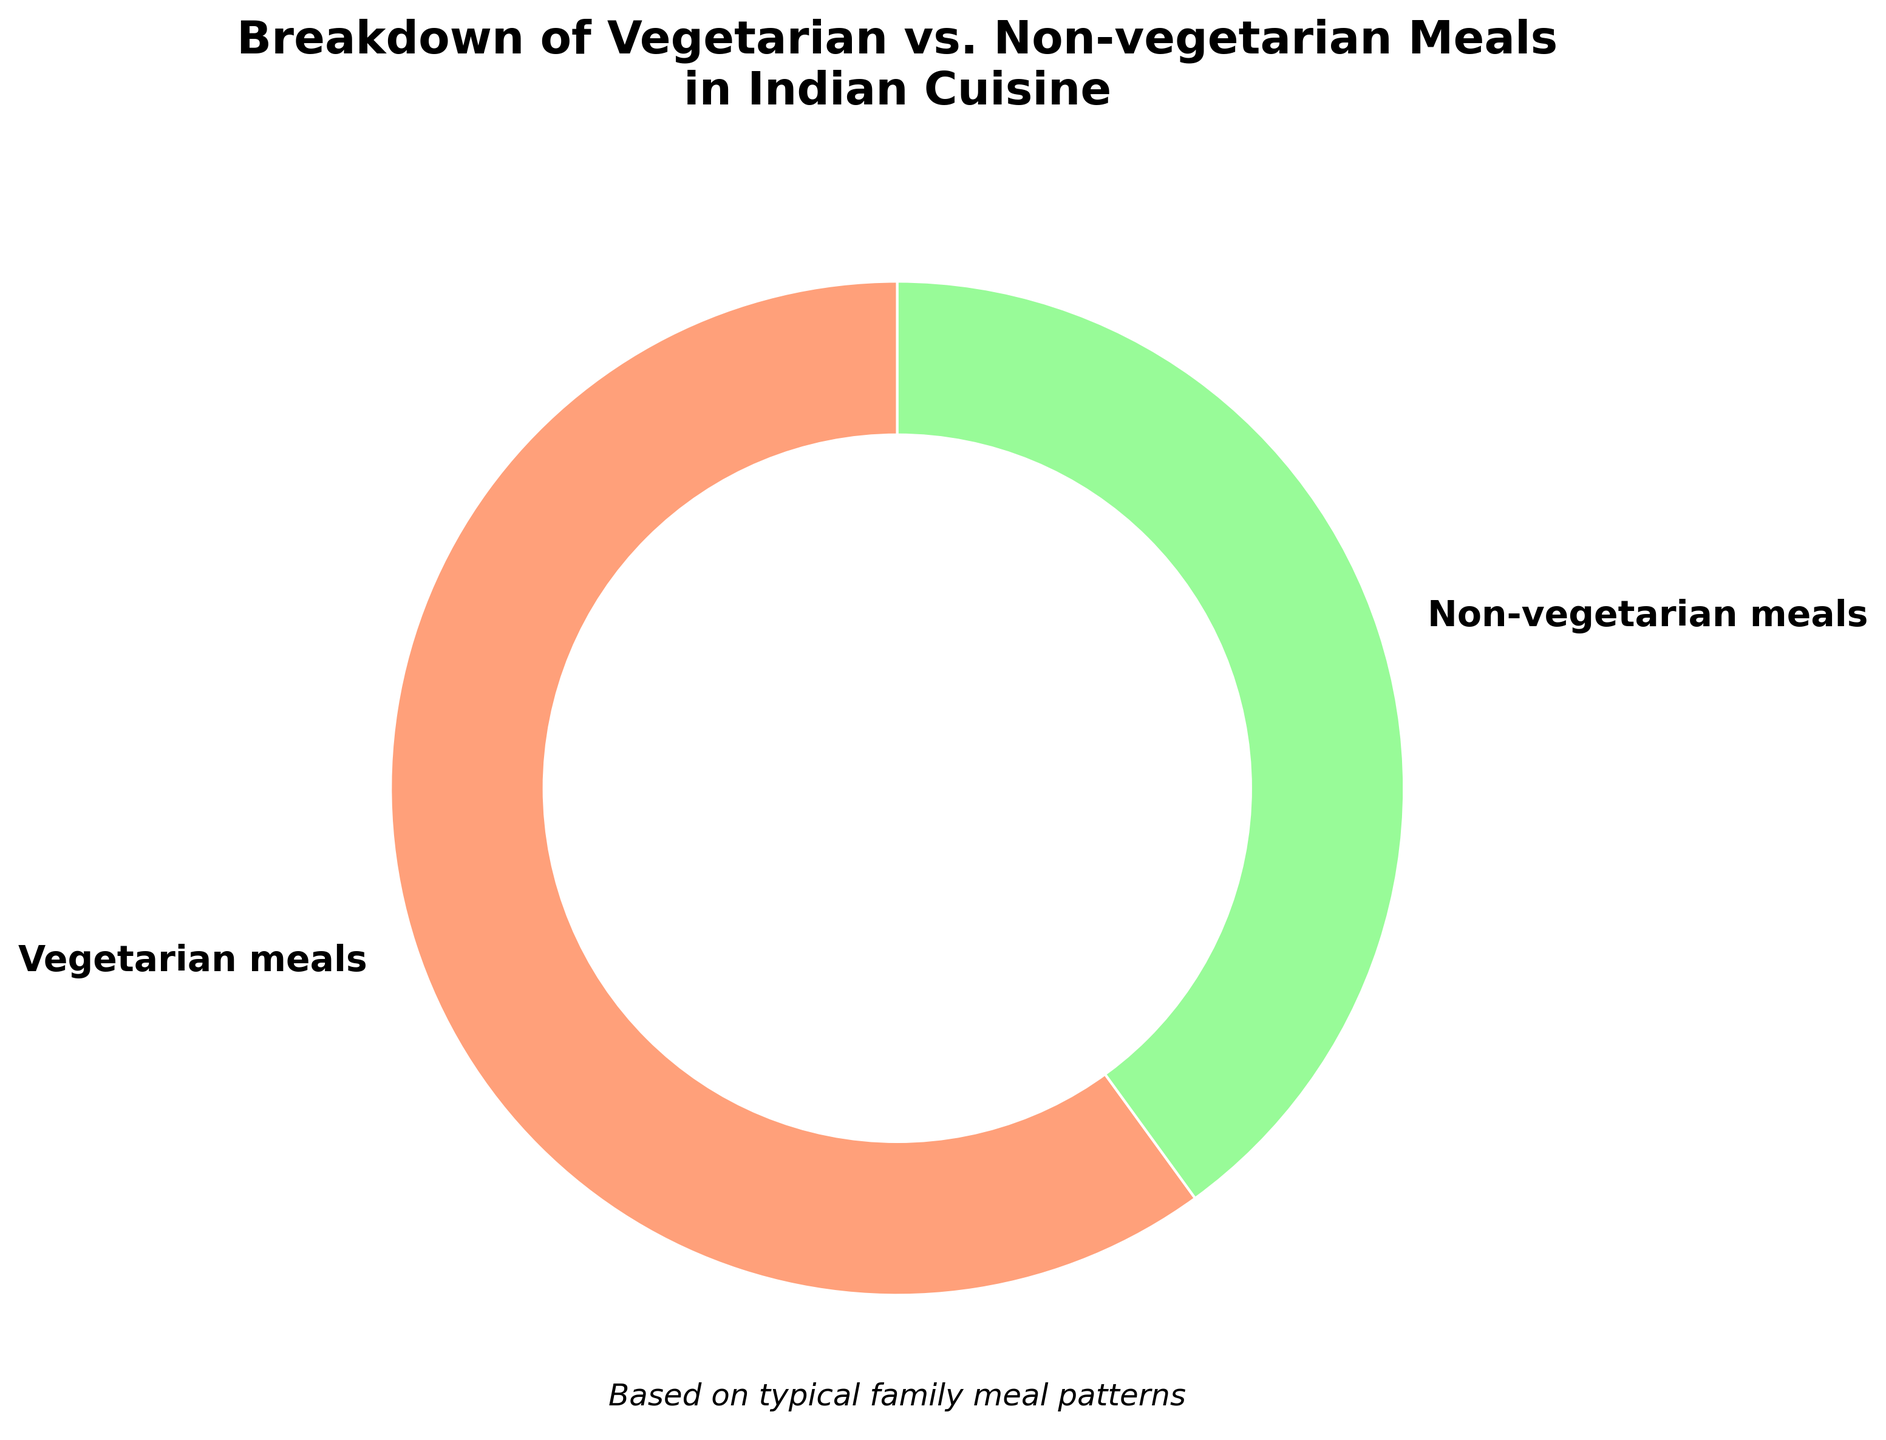What percentage of meals are vegetarian? According to the chart, 60% of the meals are vegetarian as indicated by the corresponding section of the pie chart labeled "Vegetarian meals".
Answer: 60% What percentage of meals are non-vegetarian? According to the chart, 40% of the meals are non-vegetarian as indicated by the corresponding section of the pie chart labeled "Non-vegetarian meals".
Answer: 40% Which type of meal is more common? By comparing the two sections of the pie chart, the "Vegetarian meals" section is larger than the "Non-vegetarian meals" section, indicating that vegetarian meals are more common.
Answer: Vegetarian meals By how much does the percentage of vegetarian meals exceed that of non-vegetarian meals? The chart shows vegetarian meals at 60% and non-vegetarian meals at 40%. The difference is calculated as 60% - 40% = 20%.
Answer: 20% If there were 200 meals, how many would be vegetarian? 60% of 200 meals is calculated by (60/100) * 200 = 120 meals.
Answer: 120 What is the ratio of vegetarian to non-vegetarian meals? The chart shows 60% vegetarian and 40% non-vegetarian meals. The ratio is 60:40, which simplifies to 3:2.
Answer: 3:2 Describe the colors used for the different meal types in the pie chart. The vegetarian meals section is depicted in a light peach color, while the non-vegetarian meals section is in a light green color.
Answer: Light peach for vegetarian, light green for non-vegetarian Which meal type has a larger share of the pie chart? From the visual representation of the pie chart, the "Vegetarian meals" section appears larger, indicating that vegetarian meals have a larger share.
Answer: Vegetarian meals What percentage of meals is not vegetarian? The percentage of meals that are not vegetarian is the same as the percentage of non-vegetarian meals, which is 40%.
Answer: 40% By how much would the percentage of non-vegetarian meals need to increase to equal the percentage of vegetarian meals? The current percentage of non-vegetarian meals is 40% and that of vegetarian meals is 60%. To match, non-vegetarian meals would need to increase by 60% - 40% = 20%.
Answer: 20% 